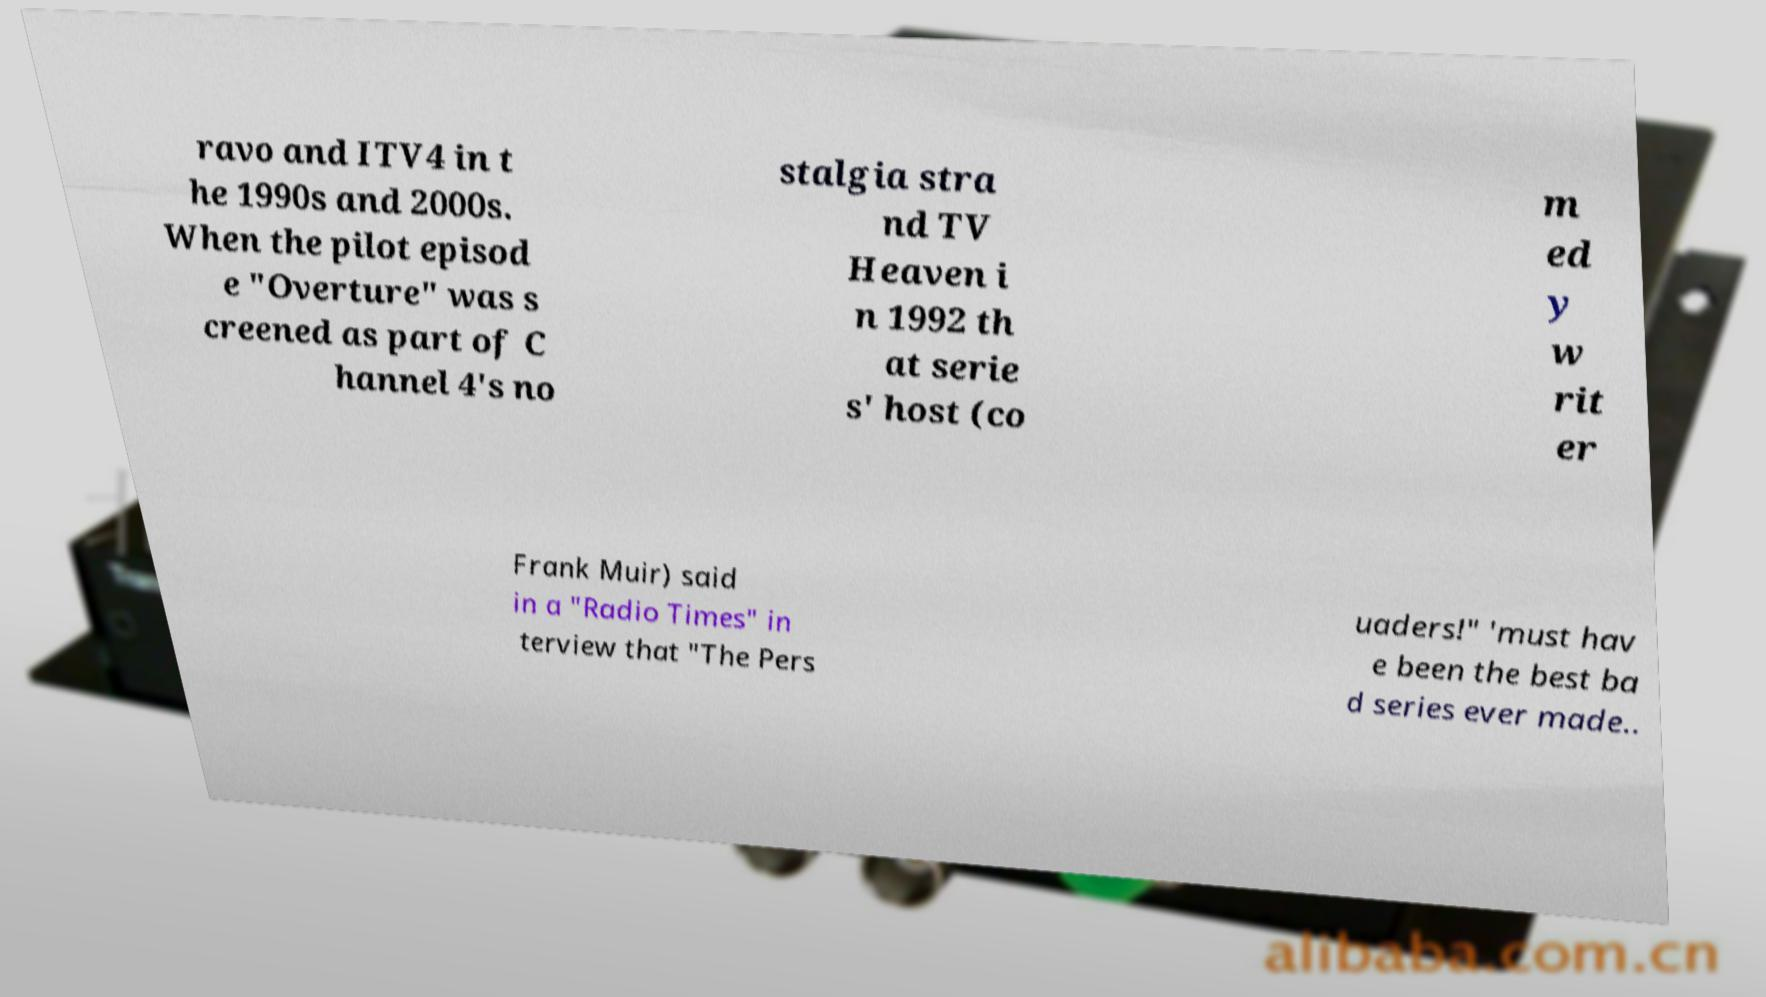What messages or text are displayed in this image? I need them in a readable, typed format. ravo and ITV4 in t he 1990s and 2000s. When the pilot episod e "Overture" was s creened as part of C hannel 4's no stalgia stra nd TV Heaven i n 1992 th at serie s' host (co m ed y w rit er Frank Muir) said in a "Radio Times" in terview that "The Pers uaders!" 'must hav e been the best ba d series ever made.. 